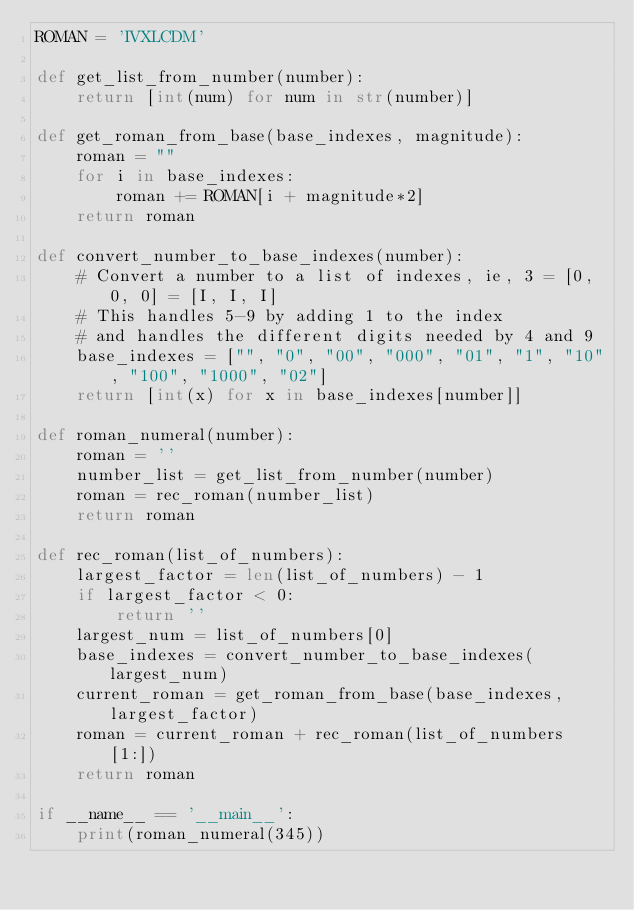Convert code to text. <code><loc_0><loc_0><loc_500><loc_500><_Python_>ROMAN = 'IVXLCDM'

def get_list_from_number(number):
    return [int(num) for num in str(number)]

def get_roman_from_base(base_indexes, magnitude):
    roman = ""
    for i in base_indexes:
        roman += ROMAN[i + magnitude*2]
    return roman

def convert_number_to_base_indexes(number):
    # Convert a number to a list of indexes, ie, 3 = [0, 0, 0] = [I, I, I]
    # This handles 5-9 by adding 1 to the index
    # and handles the different digits needed by 4 and 9
    base_indexes = ["", "0", "00", "000", "01", "1", "10", "100", "1000", "02"]
    return [int(x) for x in base_indexes[number]]

def roman_numeral(number):
    roman = ''
    number_list = get_list_from_number(number)
    roman = rec_roman(number_list)
    return roman

def rec_roman(list_of_numbers):
    largest_factor = len(list_of_numbers) - 1
    if largest_factor < 0:
        return ''
    largest_num = list_of_numbers[0]
    base_indexes = convert_number_to_base_indexes(largest_num)
    current_roman = get_roman_from_base(base_indexes, largest_factor)
    roman = current_roman + rec_roman(list_of_numbers[1:])
    return roman

if __name__ == '__main__':
    print(roman_numeral(345))
</code> 